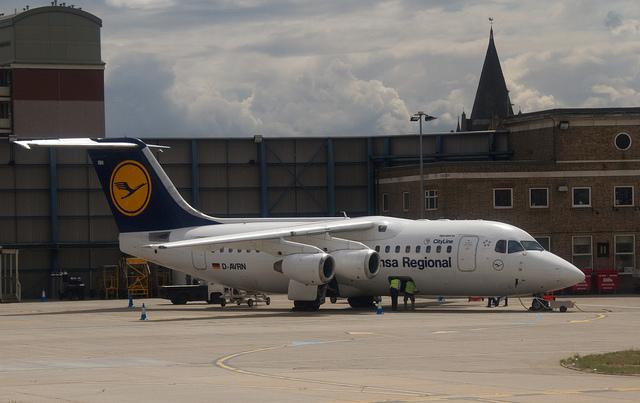What is written on the plane?
Concise answer only. Regional. Is this an urban airport?
Answer briefly. Yes. Is the plane in motion?
Be succinct. No. What color is the animal on the plane's tail?
Quick response, please. Blue. Do you see an American flag?
Write a very short answer. No. Where is this plane at?
Answer briefly. Airport. Where is the plane?
Quick response, please. Square. What color is the plane?
Short answer required. White. Overcast or sunny?
Short answer required. Overcast. Is this airport in the city or country?
Short answer required. Country. 